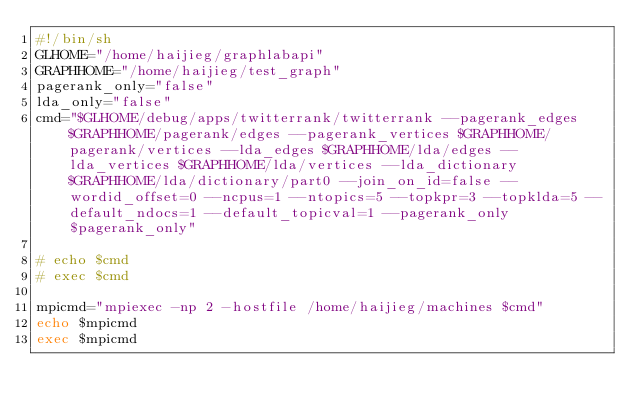<code> <loc_0><loc_0><loc_500><loc_500><_Bash_>#!/bin/sh
GLHOME="/home/haijieg/graphlabapi"
GRAPHHOME="/home/haijieg/test_graph"
pagerank_only="false"
lda_only="false"
cmd="$GLHOME/debug/apps/twitterrank/twitterrank --pagerank_edges $GRAPHHOME/pagerank/edges --pagerank_vertices $GRAPHHOME/pagerank/vertices --lda_edges $GRAPHHOME/lda/edges --lda_vertices $GRAPHHOME/lda/vertices --lda_dictionary $GRAPHHOME/lda/dictionary/part0 --join_on_id=false --wordid_offset=0 --ncpus=1 --ntopics=5 --topkpr=3 --topklda=5 --default_ndocs=1 --default_topicval=1 --pagerank_only $pagerank_only"

# echo $cmd
# exec $cmd

mpicmd="mpiexec -np 2 -hostfile /home/haijieg/machines $cmd"
echo $mpicmd
exec $mpicmd
</code> 